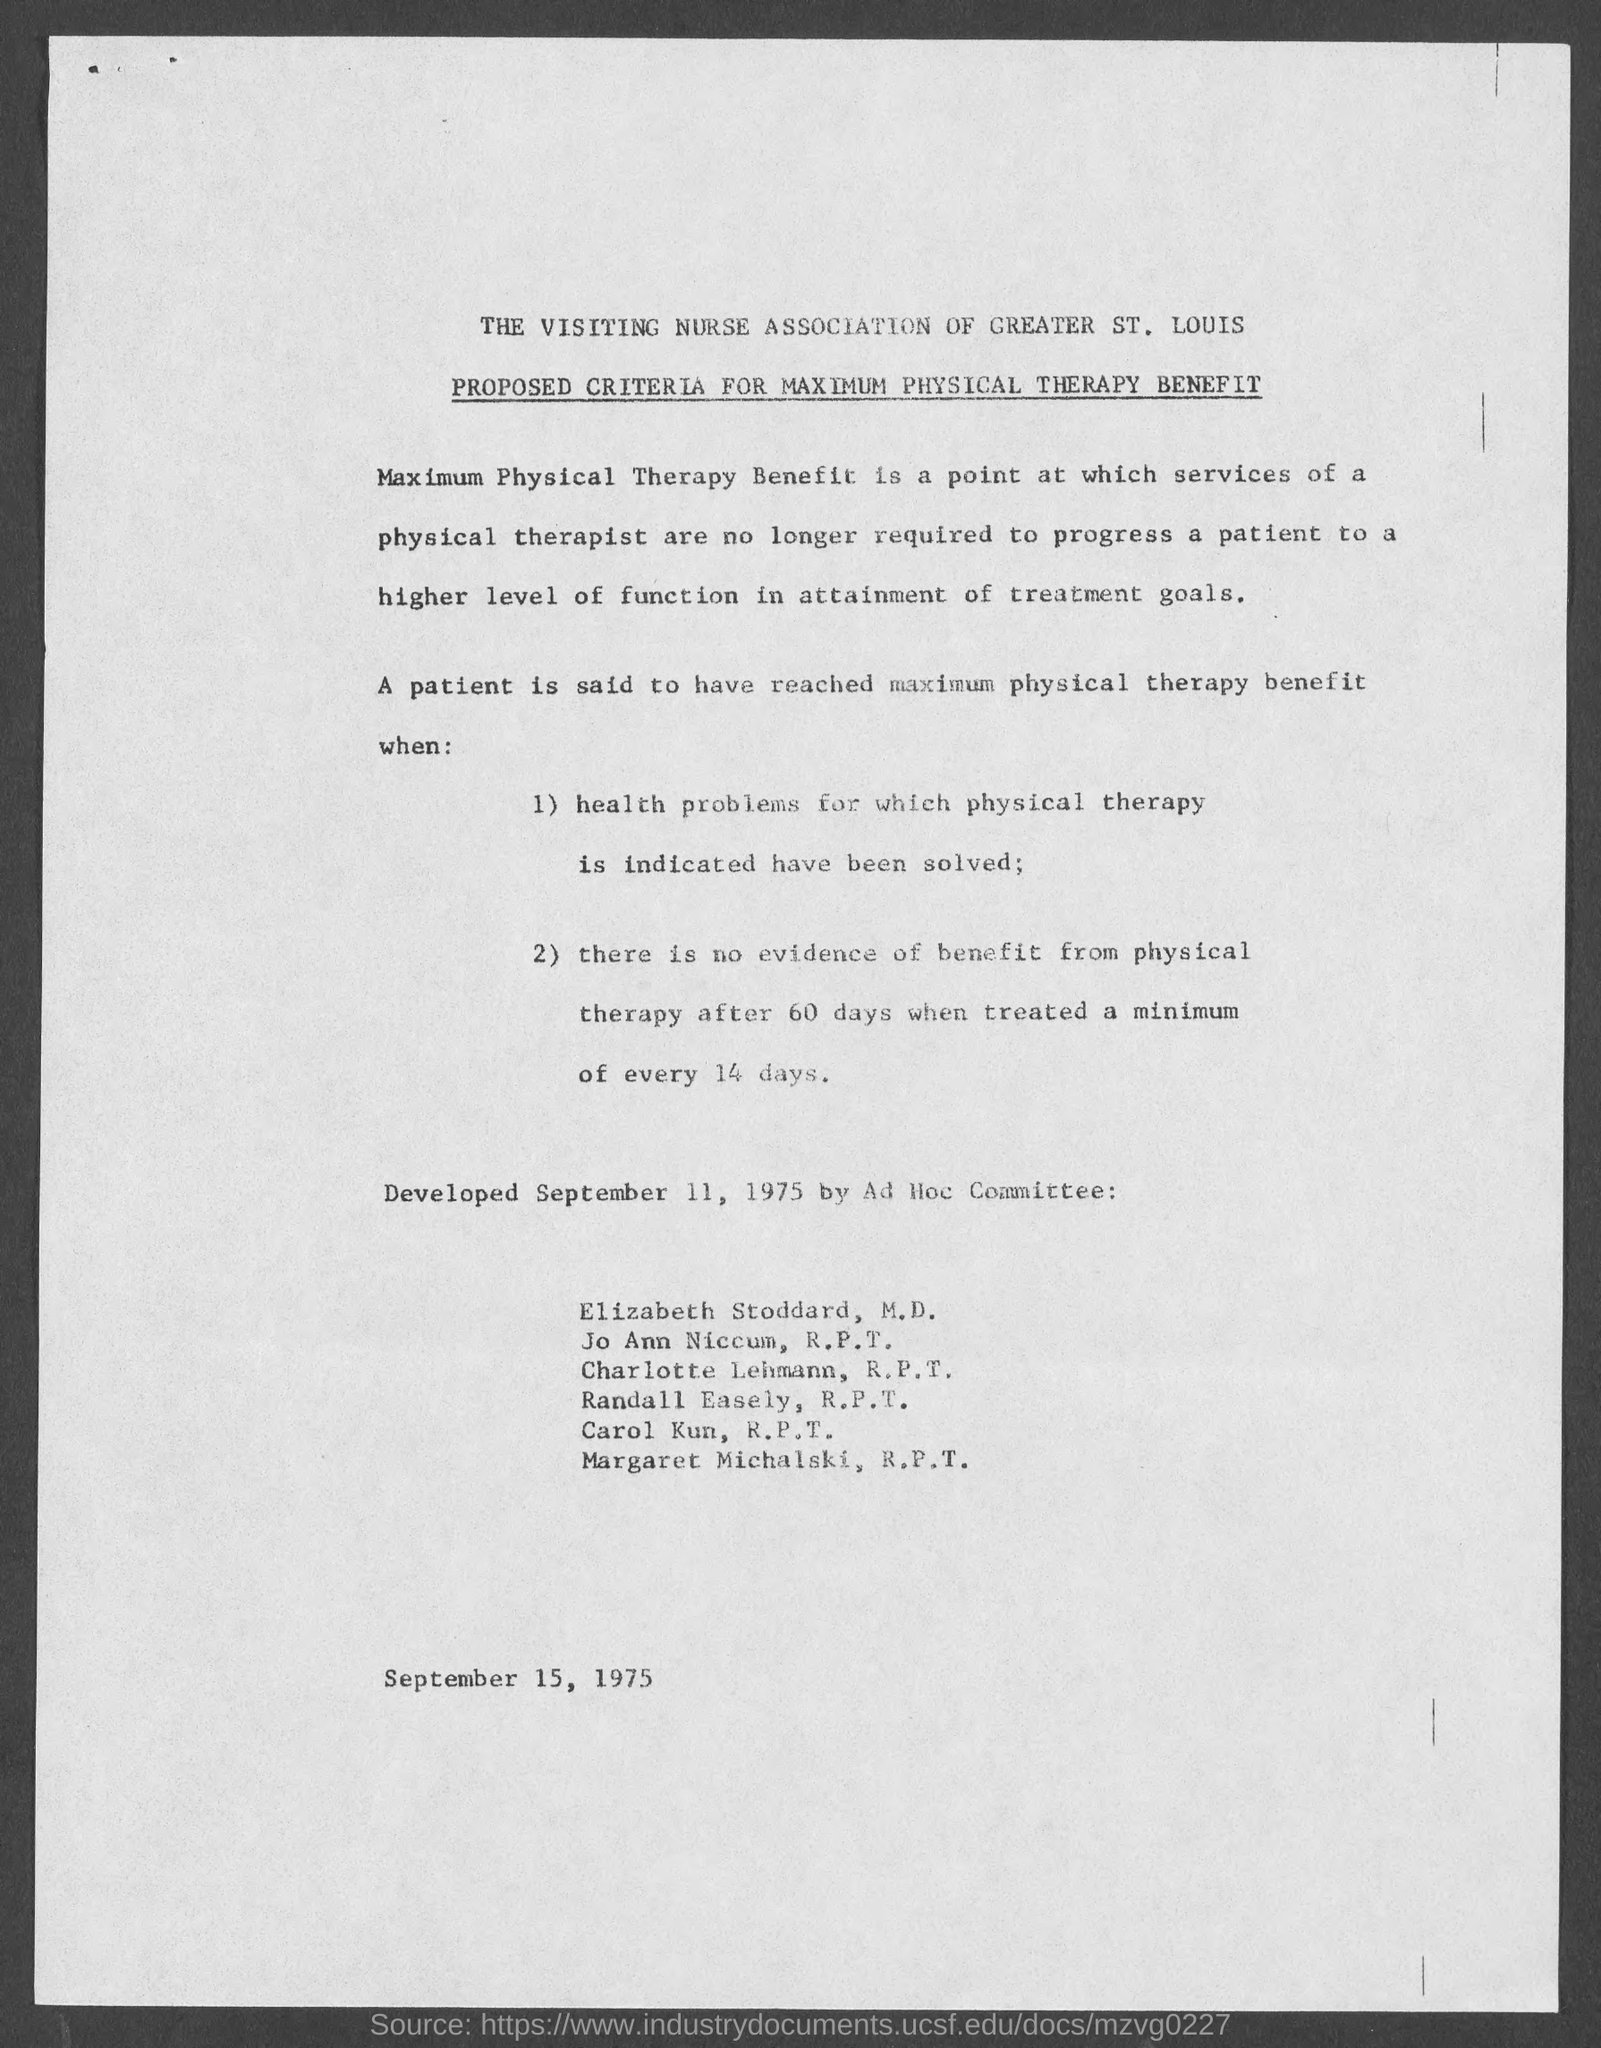What is the issued date of this document?
Keep it short and to the point. SEPTEMBER 15, 1975. 